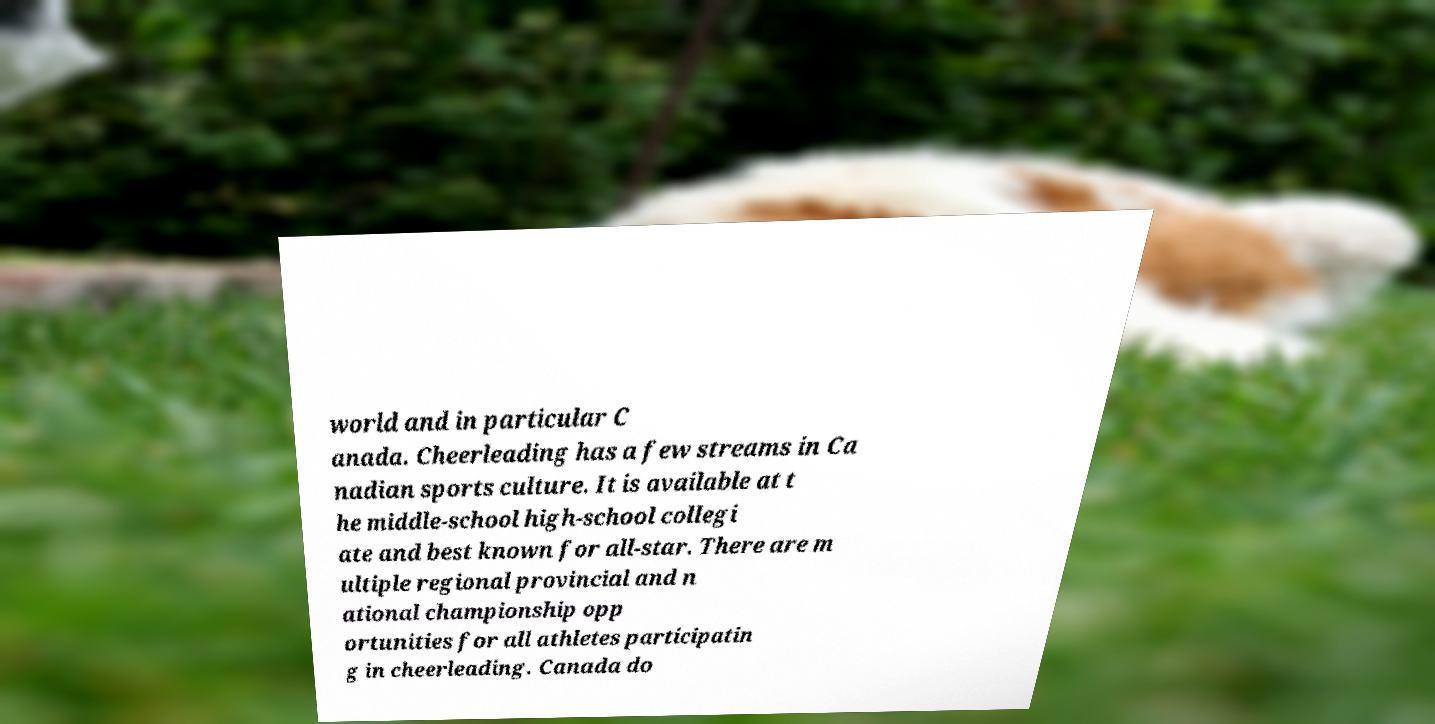Could you assist in decoding the text presented in this image and type it out clearly? world and in particular C anada. Cheerleading has a few streams in Ca nadian sports culture. It is available at t he middle-school high-school collegi ate and best known for all-star. There are m ultiple regional provincial and n ational championship opp ortunities for all athletes participatin g in cheerleading. Canada do 